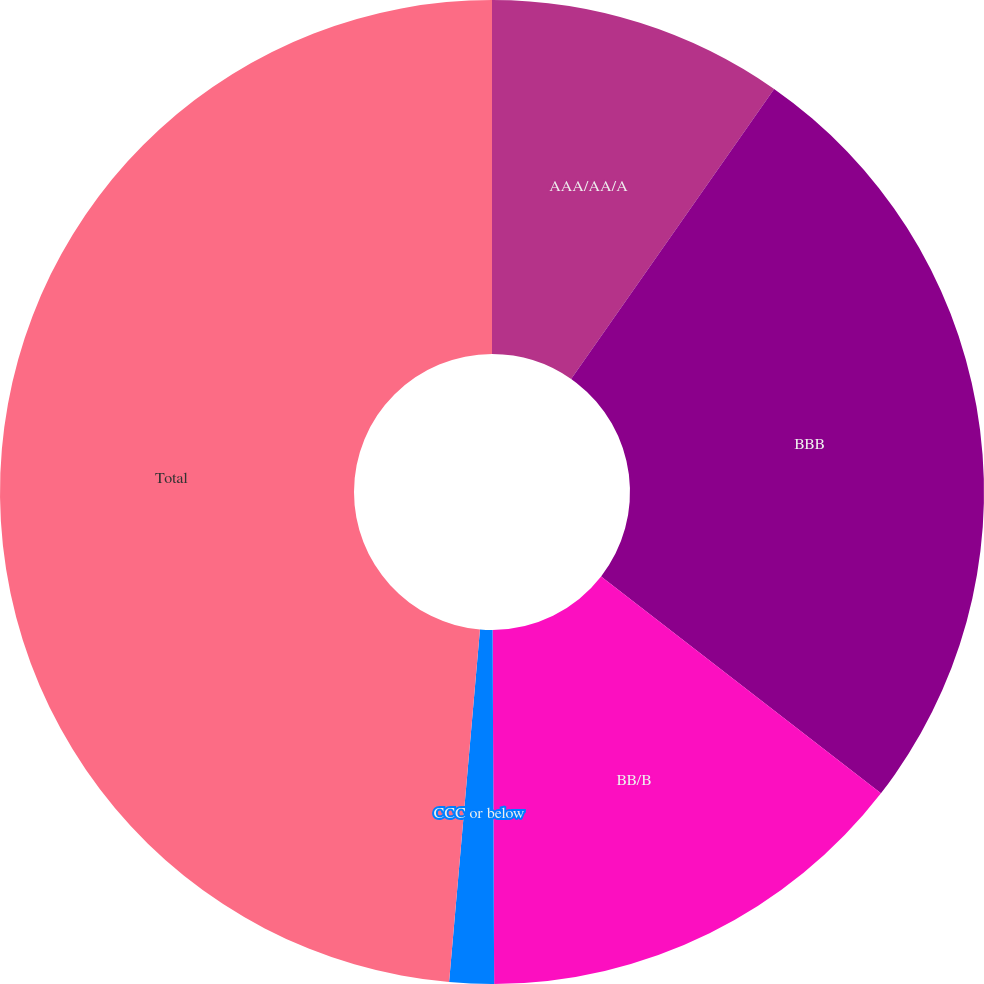Convert chart to OTSL. <chart><loc_0><loc_0><loc_500><loc_500><pie_chart><fcel>AAA/AA/A<fcel>BBB<fcel>BB/B<fcel>CCC or below<fcel>Total<nl><fcel>9.72%<fcel>25.77%<fcel>14.44%<fcel>1.46%<fcel>48.61%<nl></chart> 